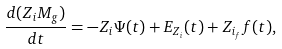Convert formula to latex. <formula><loc_0><loc_0><loc_500><loc_500>\frac { d ( Z _ { i } M _ { g } ) } { d t } = - Z _ { i } \Psi ( t ) + E _ { Z _ { i } } ( t ) + Z _ { i _ { f } } f ( t ) ,</formula> 